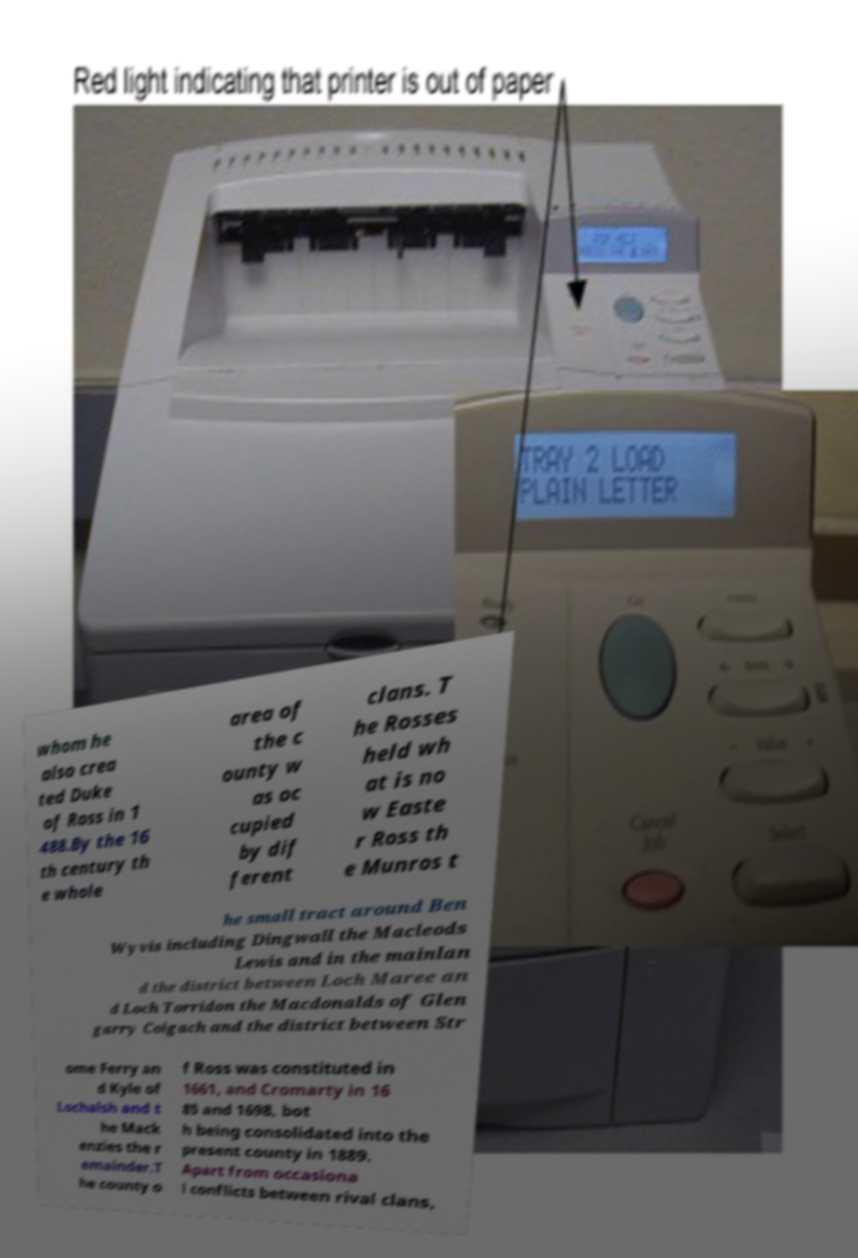Could you assist in decoding the text presented in this image and type it out clearly? whom he also crea ted Duke of Ross in 1 488.By the 16 th century th e whole area of the c ounty w as oc cupied by dif ferent clans. T he Rosses held wh at is no w Easte r Ross th e Munros t he small tract around Ben Wyvis including Dingwall the Macleods Lewis and in the mainlan d the district between Loch Maree an d Loch Torridon the Macdonalds of Glen garry Coigach and the district between Str ome Ferry an d Kyle of Lochalsh and t he Mack enzies the r emainder.T he county o f Ross was constituted in 1661, and Cromarty in 16 85 and 1698, bot h being consolidated into the present county in 1889. Apart from occasiona l conflicts between rival clans, 